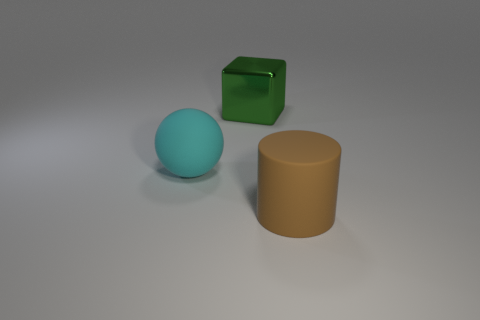Subtract all cubes. How many objects are left? 2 Subtract all cyan matte objects. Subtract all cyan balls. How many objects are left? 1 Add 2 balls. How many balls are left? 3 Add 1 cyan things. How many cyan things exist? 2 Add 3 big green metal cylinders. How many objects exist? 6 Subtract 0 red cylinders. How many objects are left? 3 Subtract all gray cylinders. Subtract all red cubes. How many cylinders are left? 1 